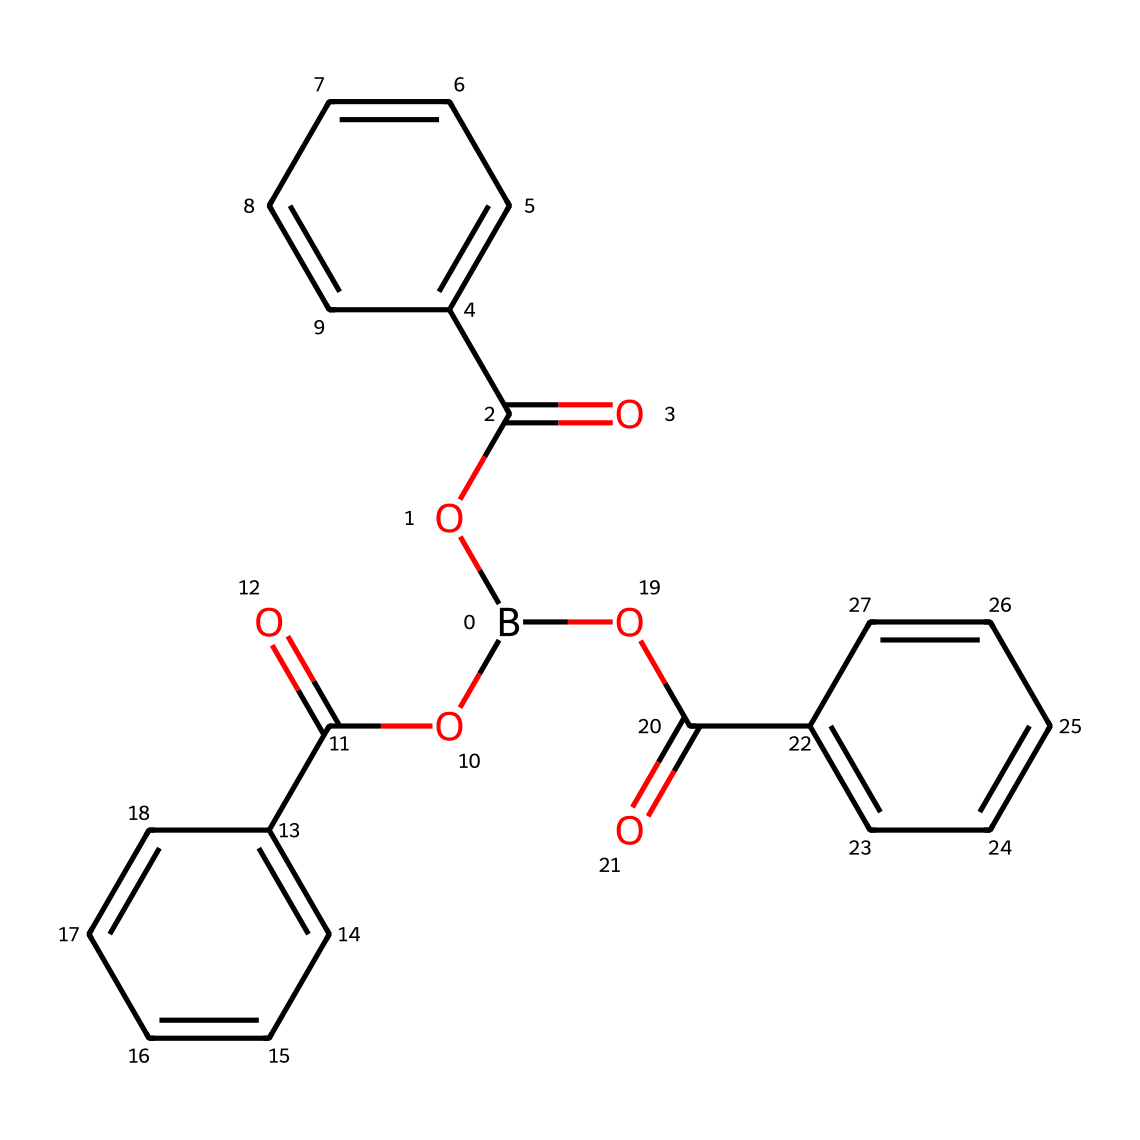What is the total number of carbon atoms in the structure? By analyzing the SMILES representation, each "C" (carbon) is counted within the parentheses and structures, totaling three distinct aromatic rings that contribute six carbons each. Counting these gives a total of 18 carbon atoms.
Answer: 18 How many ester functional groups are present in this compound? The presence of "OC(=O)" indicates ester functional groups. Each "OC(=O)" in the SMILES occurs three times, signifying three ester functionalities in this compound.
Answer: 3 What type of chemical compound is represented by the structure? The presence of boron connected to carbon and oxygen atoms, specifically with ester linkages, indicates that this compound falls under the category of boranes, which are compounds that include boron in their structure.
Answer: borane Is this chemical more likely to be hydrophilic or hydrophobic? The multiple ester functional groups (OC(=O)) suggest that the compound can interact with water, indicating a hydrophilic nature; however, the large hydrophobic aromatic rings may counterbalance this, but overall, it's likely more hydrophilic.
Answer: hydrophilic Which part of this structure is primarily responsible for its antifouling properties? The boron atom typically contributes to the effective performance in antifouling agents. The chemical structure shows that the boron atom is central to this molecular composition, indicating its direct role in antifouling effectiveness.
Answer: boron 